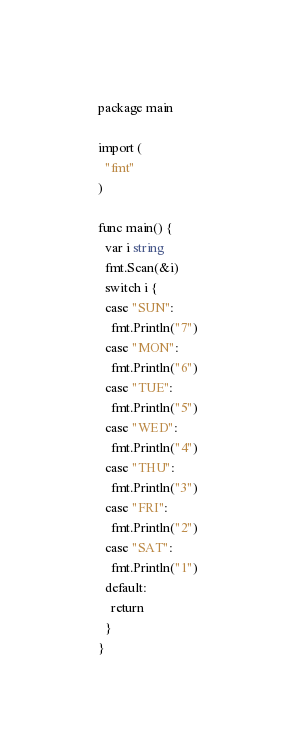Convert code to text. <code><loc_0><loc_0><loc_500><loc_500><_Go_>package main

import (
  "fmt"
)

func main() {
  var i string
  fmt.Scan(&i)
  switch i {
  case "SUN":
    fmt.Println("7")
  case "MON":
    fmt.Println("6")
  case "TUE":
    fmt.Println("5")
  case "WED":
    fmt.Println("4")
  case "THU":
    fmt.Println("3")
  case "FRI":
    fmt.Println("2")
  case "SAT":
    fmt.Println("1")
  default:
    return
  }
}</code> 